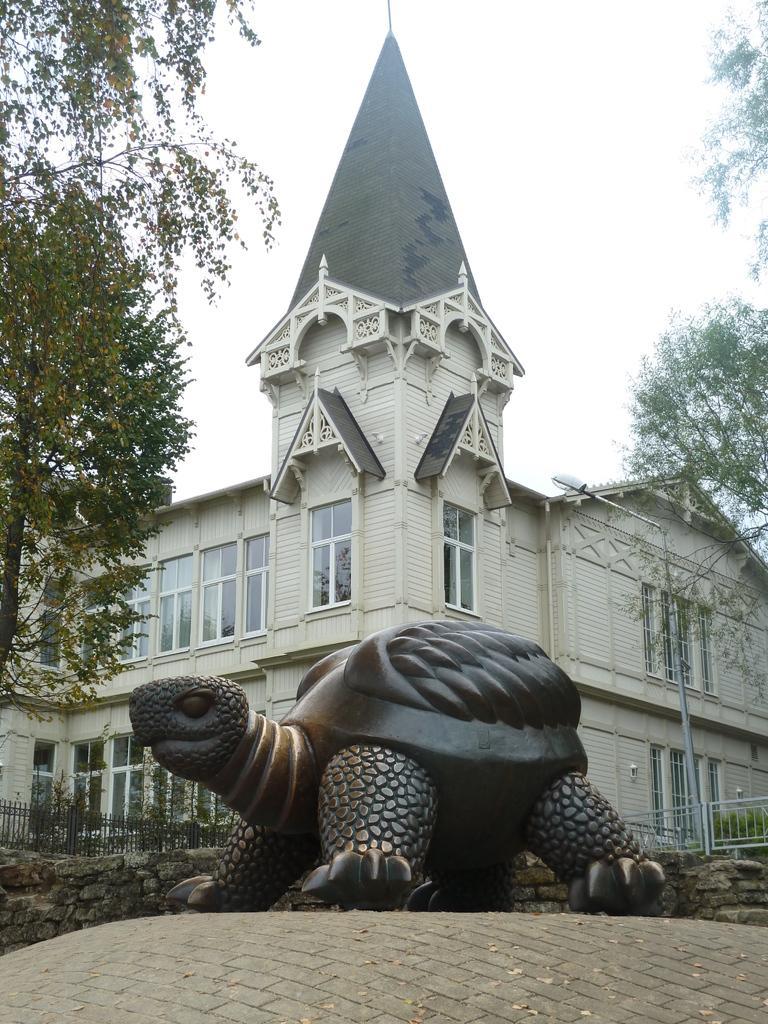Describe this image in one or two sentences. In the middle of the image we can see a sculpture, in the background we can see fence, few trees, a building and a pole. 